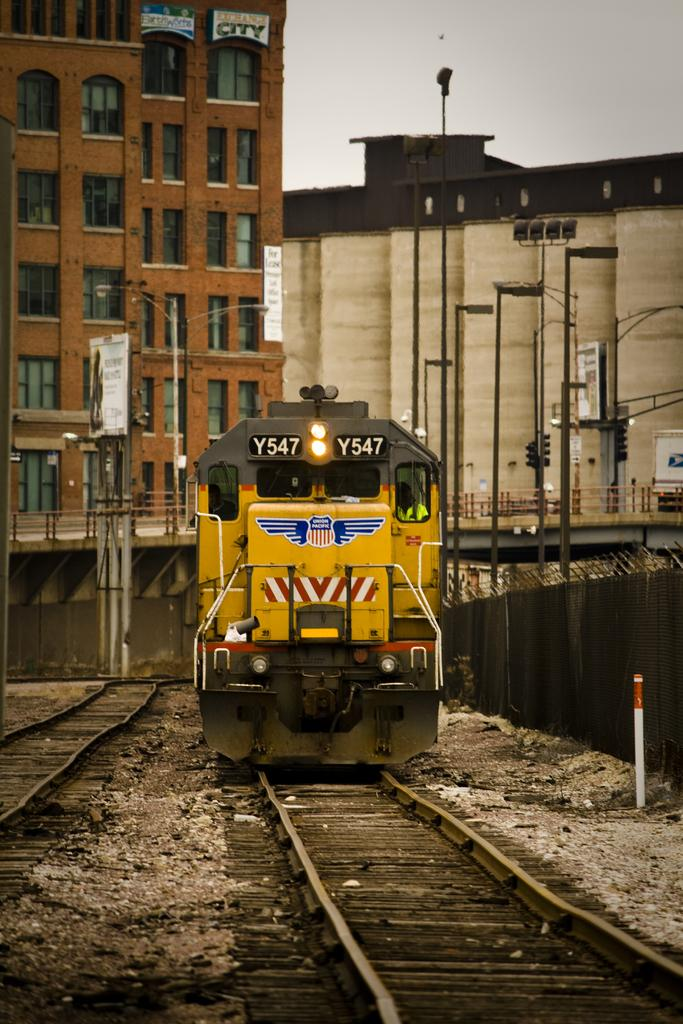What is the main subject of the image? The main subject of the image is a train. What is the train's position in relation to the track? The train is on a track. What type of barrier is present beside the train? There is fencing beside the train. What can be seen in the background of the image? There are buildings and the sky visible in the background of the image. What type of zinc is being transported by the train in the image? There is no indication of any zinc being transported by the train in the image. How many bags of grain can be seen on the train in the image? There is no grain visible on the train in the image. 